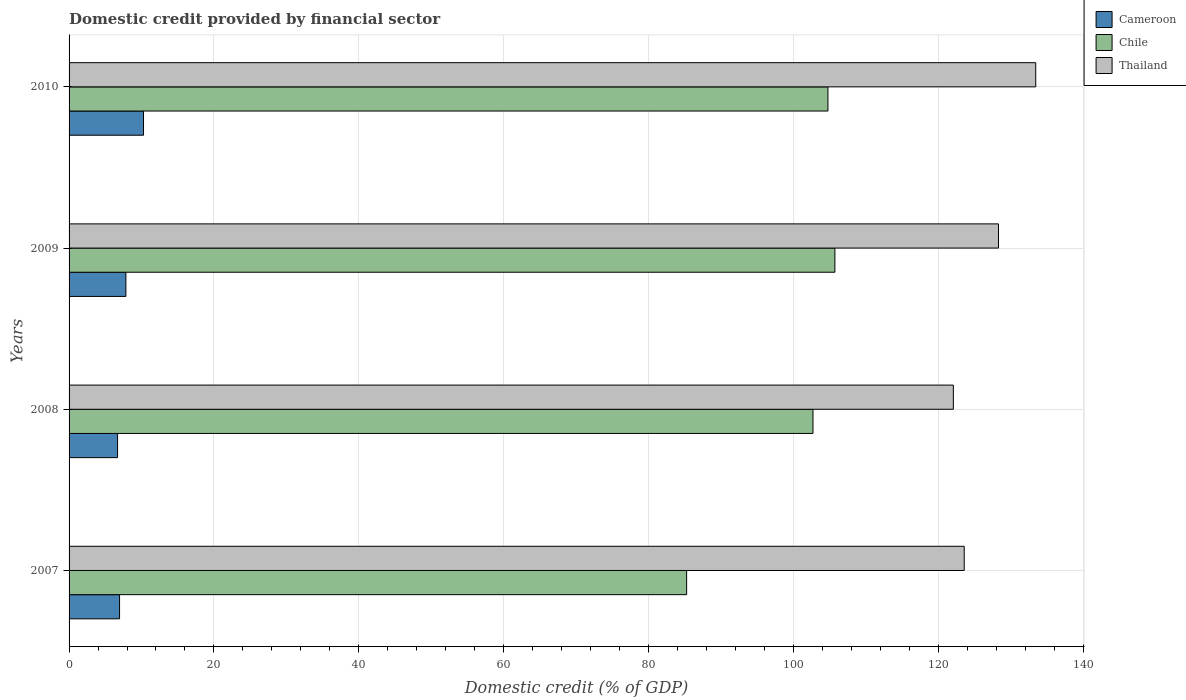How many groups of bars are there?
Provide a short and direct response. 4. What is the domestic credit in Thailand in 2009?
Your answer should be very brief. 128.32. Across all years, what is the maximum domestic credit in Thailand?
Offer a terse response. 133.46. Across all years, what is the minimum domestic credit in Cameroon?
Make the answer very short. 6.7. In which year was the domestic credit in Thailand maximum?
Make the answer very short. 2010. In which year was the domestic credit in Chile minimum?
Keep it short and to the point. 2007. What is the total domestic credit in Cameroon in the graph?
Give a very brief answer. 31.79. What is the difference between the domestic credit in Cameroon in 2008 and that in 2010?
Your answer should be compact. -3.58. What is the difference between the domestic credit in Chile in 2010 and the domestic credit in Thailand in 2007?
Your response must be concise. -18.82. What is the average domestic credit in Thailand per year?
Provide a short and direct response. 126.87. In the year 2009, what is the difference between the domestic credit in Cameroon and domestic credit in Thailand?
Provide a succinct answer. -120.48. In how many years, is the domestic credit in Thailand greater than 92 %?
Keep it short and to the point. 4. What is the ratio of the domestic credit in Cameroon in 2008 to that in 2010?
Provide a short and direct response. 0.65. Is the domestic credit in Chile in 2007 less than that in 2009?
Your answer should be compact. Yes. What is the difference between the highest and the second highest domestic credit in Thailand?
Make the answer very short. 5.14. What is the difference between the highest and the lowest domestic credit in Thailand?
Your response must be concise. 11.37. In how many years, is the domestic credit in Chile greater than the average domestic credit in Chile taken over all years?
Your answer should be compact. 3. What does the 3rd bar from the top in 2009 represents?
Make the answer very short. Cameroon. What does the 2nd bar from the bottom in 2008 represents?
Make the answer very short. Chile. How many bars are there?
Make the answer very short. 12. How many years are there in the graph?
Your answer should be compact. 4. What is the difference between two consecutive major ticks on the X-axis?
Provide a succinct answer. 20. Are the values on the major ticks of X-axis written in scientific E-notation?
Your answer should be very brief. No. Does the graph contain any zero values?
Keep it short and to the point. No. Where does the legend appear in the graph?
Provide a succinct answer. Top right. How many legend labels are there?
Offer a very short reply. 3. What is the title of the graph?
Your answer should be compact. Domestic credit provided by financial sector. Does "Suriname" appear as one of the legend labels in the graph?
Your response must be concise. No. What is the label or title of the X-axis?
Provide a short and direct response. Domestic credit (% of GDP). What is the label or title of the Y-axis?
Your response must be concise. Years. What is the Domestic credit (% of GDP) of Cameroon in 2007?
Give a very brief answer. 6.97. What is the Domestic credit (% of GDP) in Chile in 2007?
Your answer should be compact. 85.26. What is the Domestic credit (% of GDP) of Thailand in 2007?
Offer a very short reply. 123.59. What is the Domestic credit (% of GDP) of Cameroon in 2008?
Ensure brevity in your answer.  6.7. What is the Domestic credit (% of GDP) in Chile in 2008?
Your answer should be compact. 102.71. What is the Domestic credit (% of GDP) of Thailand in 2008?
Provide a short and direct response. 122.09. What is the Domestic credit (% of GDP) in Cameroon in 2009?
Provide a short and direct response. 7.85. What is the Domestic credit (% of GDP) of Chile in 2009?
Provide a succinct answer. 105.73. What is the Domestic credit (% of GDP) in Thailand in 2009?
Give a very brief answer. 128.32. What is the Domestic credit (% of GDP) of Cameroon in 2010?
Provide a short and direct response. 10.28. What is the Domestic credit (% of GDP) of Chile in 2010?
Your response must be concise. 104.78. What is the Domestic credit (% of GDP) of Thailand in 2010?
Your answer should be very brief. 133.46. Across all years, what is the maximum Domestic credit (% of GDP) of Cameroon?
Your answer should be compact. 10.28. Across all years, what is the maximum Domestic credit (% of GDP) of Chile?
Provide a succinct answer. 105.73. Across all years, what is the maximum Domestic credit (% of GDP) of Thailand?
Offer a very short reply. 133.46. Across all years, what is the minimum Domestic credit (% of GDP) in Cameroon?
Offer a terse response. 6.7. Across all years, what is the minimum Domestic credit (% of GDP) of Chile?
Make the answer very short. 85.26. Across all years, what is the minimum Domestic credit (% of GDP) in Thailand?
Give a very brief answer. 122.09. What is the total Domestic credit (% of GDP) of Cameroon in the graph?
Make the answer very short. 31.79. What is the total Domestic credit (% of GDP) in Chile in the graph?
Ensure brevity in your answer.  398.48. What is the total Domestic credit (% of GDP) in Thailand in the graph?
Your answer should be very brief. 507.47. What is the difference between the Domestic credit (% of GDP) in Cameroon in 2007 and that in 2008?
Provide a succinct answer. 0.27. What is the difference between the Domestic credit (% of GDP) in Chile in 2007 and that in 2008?
Your response must be concise. -17.45. What is the difference between the Domestic credit (% of GDP) of Thailand in 2007 and that in 2008?
Provide a short and direct response. 1.5. What is the difference between the Domestic credit (% of GDP) of Cameroon in 2007 and that in 2009?
Your answer should be very brief. -0.87. What is the difference between the Domestic credit (% of GDP) of Chile in 2007 and that in 2009?
Your answer should be very brief. -20.47. What is the difference between the Domestic credit (% of GDP) of Thailand in 2007 and that in 2009?
Keep it short and to the point. -4.73. What is the difference between the Domestic credit (% of GDP) of Cameroon in 2007 and that in 2010?
Your answer should be very brief. -3.31. What is the difference between the Domestic credit (% of GDP) in Chile in 2007 and that in 2010?
Offer a terse response. -19.51. What is the difference between the Domestic credit (% of GDP) in Thailand in 2007 and that in 2010?
Your answer should be very brief. -9.87. What is the difference between the Domestic credit (% of GDP) in Cameroon in 2008 and that in 2009?
Your response must be concise. -1.15. What is the difference between the Domestic credit (% of GDP) of Chile in 2008 and that in 2009?
Provide a succinct answer. -3.02. What is the difference between the Domestic credit (% of GDP) in Thailand in 2008 and that in 2009?
Give a very brief answer. -6.23. What is the difference between the Domestic credit (% of GDP) in Cameroon in 2008 and that in 2010?
Provide a succinct answer. -3.58. What is the difference between the Domestic credit (% of GDP) of Chile in 2008 and that in 2010?
Your answer should be compact. -2.07. What is the difference between the Domestic credit (% of GDP) of Thailand in 2008 and that in 2010?
Keep it short and to the point. -11.37. What is the difference between the Domestic credit (% of GDP) of Cameroon in 2009 and that in 2010?
Make the answer very short. -2.43. What is the difference between the Domestic credit (% of GDP) of Chile in 2009 and that in 2010?
Your answer should be compact. 0.96. What is the difference between the Domestic credit (% of GDP) in Thailand in 2009 and that in 2010?
Your answer should be compact. -5.14. What is the difference between the Domestic credit (% of GDP) of Cameroon in 2007 and the Domestic credit (% of GDP) of Chile in 2008?
Keep it short and to the point. -95.74. What is the difference between the Domestic credit (% of GDP) of Cameroon in 2007 and the Domestic credit (% of GDP) of Thailand in 2008?
Your answer should be very brief. -115.12. What is the difference between the Domestic credit (% of GDP) in Chile in 2007 and the Domestic credit (% of GDP) in Thailand in 2008?
Keep it short and to the point. -36.83. What is the difference between the Domestic credit (% of GDP) in Cameroon in 2007 and the Domestic credit (% of GDP) in Chile in 2009?
Your response must be concise. -98.76. What is the difference between the Domestic credit (% of GDP) of Cameroon in 2007 and the Domestic credit (% of GDP) of Thailand in 2009?
Offer a terse response. -121.35. What is the difference between the Domestic credit (% of GDP) of Chile in 2007 and the Domestic credit (% of GDP) of Thailand in 2009?
Offer a very short reply. -43.06. What is the difference between the Domestic credit (% of GDP) of Cameroon in 2007 and the Domestic credit (% of GDP) of Chile in 2010?
Your response must be concise. -97.8. What is the difference between the Domestic credit (% of GDP) in Cameroon in 2007 and the Domestic credit (% of GDP) in Thailand in 2010?
Give a very brief answer. -126.49. What is the difference between the Domestic credit (% of GDP) in Chile in 2007 and the Domestic credit (% of GDP) in Thailand in 2010?
Keep it short and to the point. -48.2. What is the difference between the Domestic credit (% of GDP) of Cameroon in 2008 and the Domestic credit (% of GDP) of Chile in 2009?
Offer a very short reply. -99.04. What is the difference between the Domestic credit (% of GDP) of Cameroon in 2008 and the Domestic credit (% of GDP) of Thailand in 2009?
Provide a short and direct response. -121.62. What is the difference between the Domestic credit (% of GDP) of Chile in 2008 and the Domestic credit (% of GDP) of Thailand in 2009?
Keep it short and to the point. -25.61. What is the difference between the Domestic credit (% of GDP) in Cameroon in 2008 and the Domestic credit (% of GDP) in Chile in 2010?
Your response must be concise. -98.08. What is the difference between the Domestic credit (% of GDP) in Cameroon in 2008 and the Domestic credit (% of GDP) in Thailand in 2010?
Your response must be concise. -126.77. What is the difference between the Domestic credit (% of GDP) of Chile in 2008 and the Domestic credit (% of GDP) of Thailand in 2010?
Offer a very short reply. -30.75. What is the difference between the Domestic credit (% of GDP) of Cameroon in 2009 and the Domestic credit (% of GDP) of Chile in 2010?
Provide a succinct answer. -96.93. What is the difference between the Domestic credit (% of GDP) in Cameroon in 2009 and the Domestic credit (% of GDP) in Thailand in 2010?
Your answer should be compact. -125.62. What is the difference between the Domestic credit (% of GDP) of Chile in 2009 and the Domestic credit (% of GDP) of Thailand in 2010?
Keep it short and to the point. -27.73. What is the average Domestic credit (% of GDP) in Cameroon per year?
Your answer should be very brief. 7.95. What is the average Domestic credit (% of GDP) in Chile per year?
Your answer should be very brief. 99.62. What is the average Domestic credit (% of GDP) in Thailand per year?
Offer a very short reply. 126.87. In the year 2007, what is the difference between the Domestic credit (% of GDP) in Cameroon and Domestic credit (% of GDP) in Chile?
Provide a succinct answer. -78.29. In the year 2007, what is the difference between the Domestic credit (% of GDP) in Cameroon and Domestic credit (% of GDP) in Thailand?
Your answer should be very brief. -116.62. In the year 2007, what is the difference between the Domestic credit (% of GDP) in Chile and Domestic credit (% of GDP) in Thailand?
Keep it short and to the point. -38.33. In the year 2008, what is the difference between the Domestic credit (% of GDP) in Cameroon and Domestic credit (% of GDP) in Chile?
Give a very brief answer. -96.01. In the year 2008, what is the difference between the Domestic credit (% of GDP) of Cameroon and Domestic credit (% of GDP) of Thailand?
Provide a short and direct response. -115.39. In the year 2008, what is the difference between the Domestic credit (% of GDP) in Chile and Domestic credit (% of GDP) in Thailand?
Offer a very short reply. -19.38. In the year 2009, what is the difference between the Domestic credit (% of GDP) in Cameroon and Domestic credit (% of GDP) in Chile?
Your answer should be compact. -97.89. In the year 2009, what is the difference between the Domestic credit (% of GDP) of Cameroon and Domestic credit (% of GDP) of Thailand?
Offer a very short reply. -120.48. In the year 2009, what is the difference between the Domestic credit (% of GDP) in Chile and Domestic credit (% of GDP) in Thailand?
Give a very brief answer. -22.59. In the year 2010, what is the difference between the Domestic credit (% of GDP) of Cameroon and Domestic credit (% of GDP) of Chile?
Offer a very short reply. -94.5. In the year 2010, what is the difference between the Domestic credit (% of GDP) in Cameroon and Domestic credit (% of GDP) in Thailand?
Provide a succinct answer. -123.19. In the year 2010, what is the difference between the Domestic credit (% of GDP) in Chile and Domestic credit (% of GDP) in Thailand?
Provide a short and direct response. -28.69. What is the ratio of the Domestic credit (% of GDP) in Cameroon in 2007 to that in 2008?
Make the answer very short. 1.04. What is the ratio of the Domestic credit (% of GDP) of Chile in 2007 to that in 2008?
Provide a short and direct response. 0.83. What is the ratio of the Domestic credit (% of GDP) of Thailand in 2007 to that in 2008?
Provide a succinct answer. 1.01. What is the ratio of the Domestic credit (% of GDP) in Cameroon in 2007 to that in 2009?
Keep it short and to the point. 0.89. What is the ratio of the Domestic credit (% of GDP) of Chile in 2007 to that in 2009?
Offer a very short reply. 0.81. What is the ratio of the Domestic credit (% of GDP) of Thailand in 2007 to that in 2009?
Give a very brief answer. 0.96. What is the ratio of the Domestic credit (% of GDP) of Cameroon in 2007 to that in 2010?
Provide a short and direct response. 0.68. What is the ratio of the Domestic credit (% of GDP) in Chile in 2007 to that in 2010?
Provide a short and direct response. 0.81. What is the ratio of the Domestic credit (% of GDP) in Thailand in 2007 to that in 2010?
Your answer should be very brief. 0.93. What is the ratio of the Domestic credit (% of GDP) in Cameroon in 2008 to that in 2009?
Offer a very short reply. 0.85. What is the ratio of the Domestic credit (% of GDP) in Chile in 2008 to that in 2009?
Offer a terse response. 0.97. What is the ratio of the Domestic credit (% of GDP) in Thailand in 2008 to that in 2009?
Your answer should be compact. 0.95. What is the ratio of the Domestic credit (% of GDP) of Cameroon in 2008 to that in 2010?
Provide a short and direct response. 0.65. What is the ratio of the Domestic credit (% of GDP) of Chile in 2008 to that in 2010?
Your answer should be very brief. 0.98. What is the ratio of the Domestic credit (% of GDP) in Thailand in 2008 to that in 2010?
Your answer should be very brief. 0.91. What is the ratio of the Domestic credit (% of GDP) in Cameroon in 2009 to that in 2010?
Keep it short and to the point. 0.76. What is the ratio of the Domestic credit (% of GDP) in Chile in 2009 to that in 2010?
Offer a very short reply. 1.01. What is the ratio of the Domestic credit (% of GDP) of Thailand in 2009 to that in 2010?
Provide a short and direct response. 0.96. What is the difference between the highest and the second highest Domestic credit (% of GDP) in Cameroon?
Your response must be concise. 2.43. What is the difference between the highest and the second highest Domestic credit (% of GDP) of Chile?
Your response must be concise. 0.96. What is the difference between the highest and the second highest Domestic credit (% of GDP) in Thailand?
Give a very brief answer. 5.14. What is the difference between the highest and the lowest Domestic credit (% of GDP) of Cameroon?
Provide a short and direct response. 3.58. What is the difference between the highest and the lowest Domestic credit (% of GDP) in Chile?
Offer a very short reply. 20.47. What is the difference between the highest and the lowest Domestic credit (% of GDP) of Thailand?
Your answer should be compact. 11.37. 